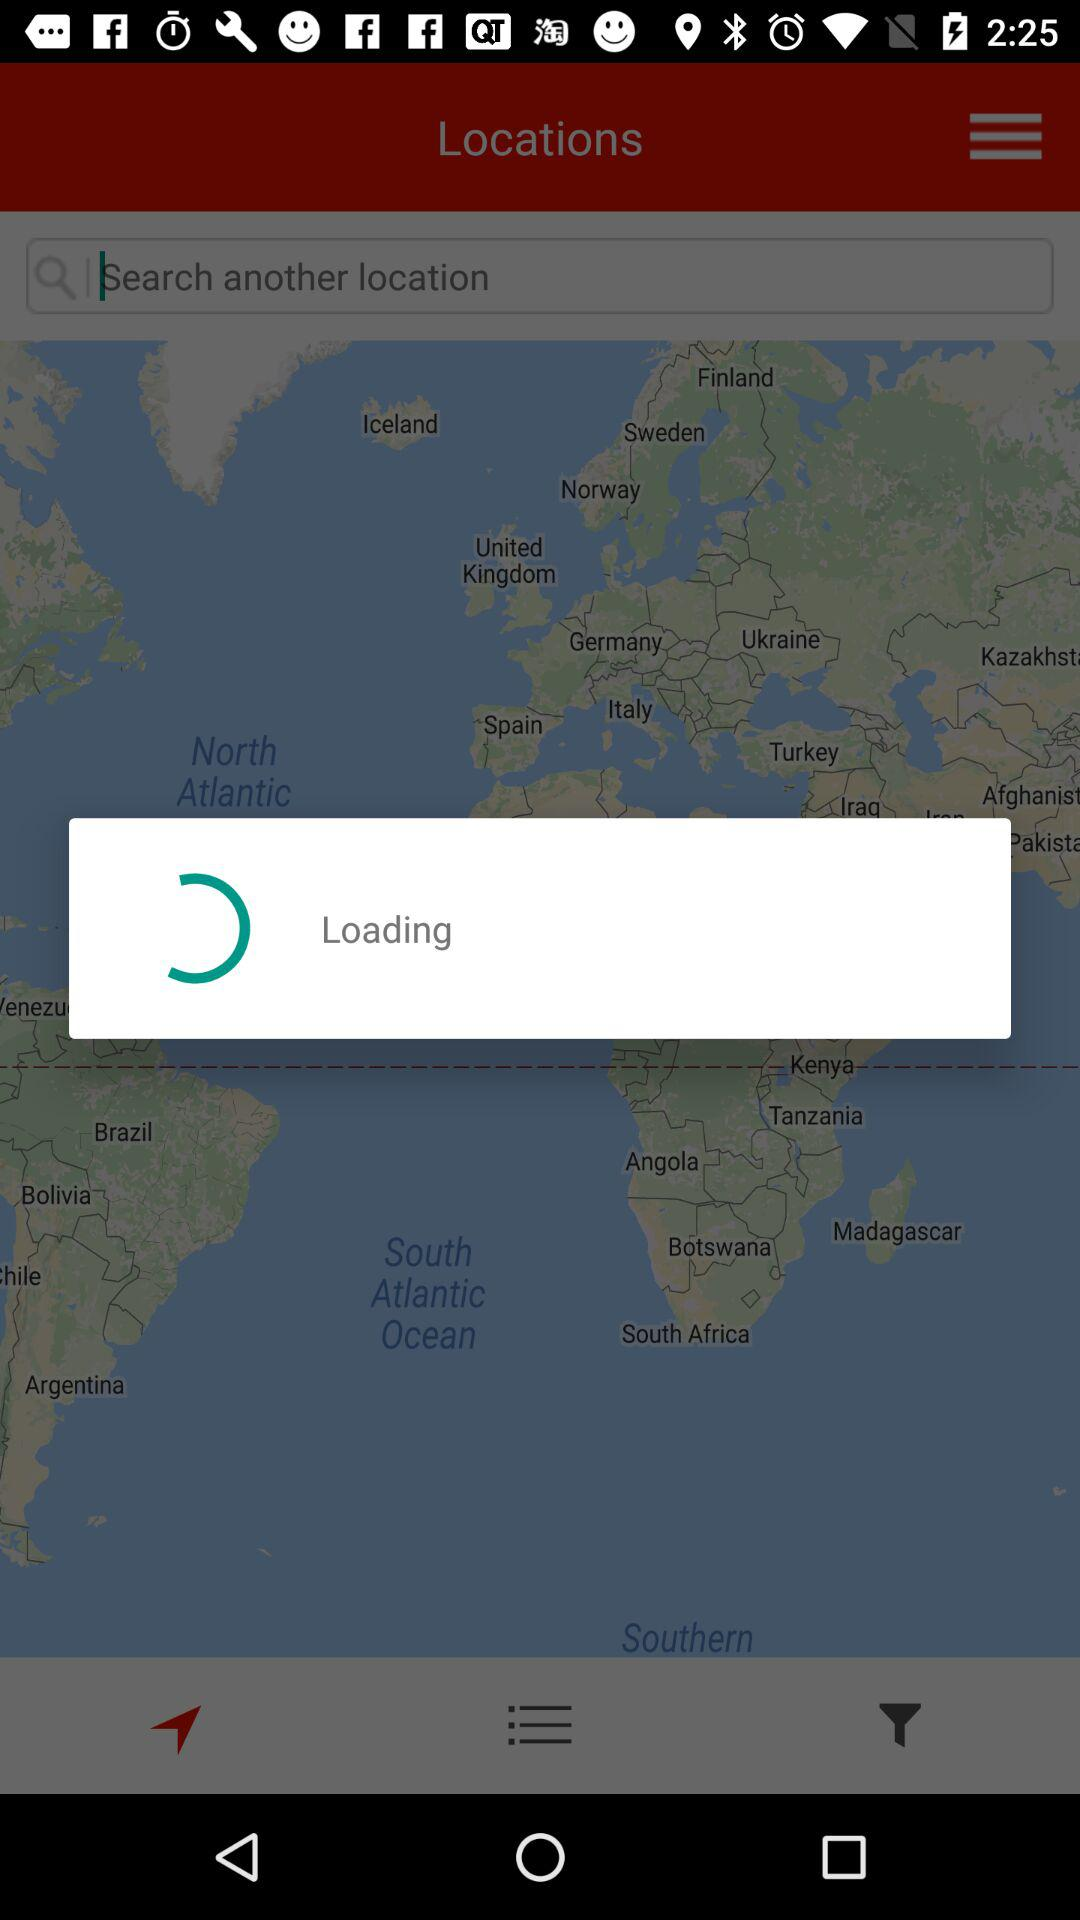What is the name of the copyright bank? The name of the copyright bank is Santander. 